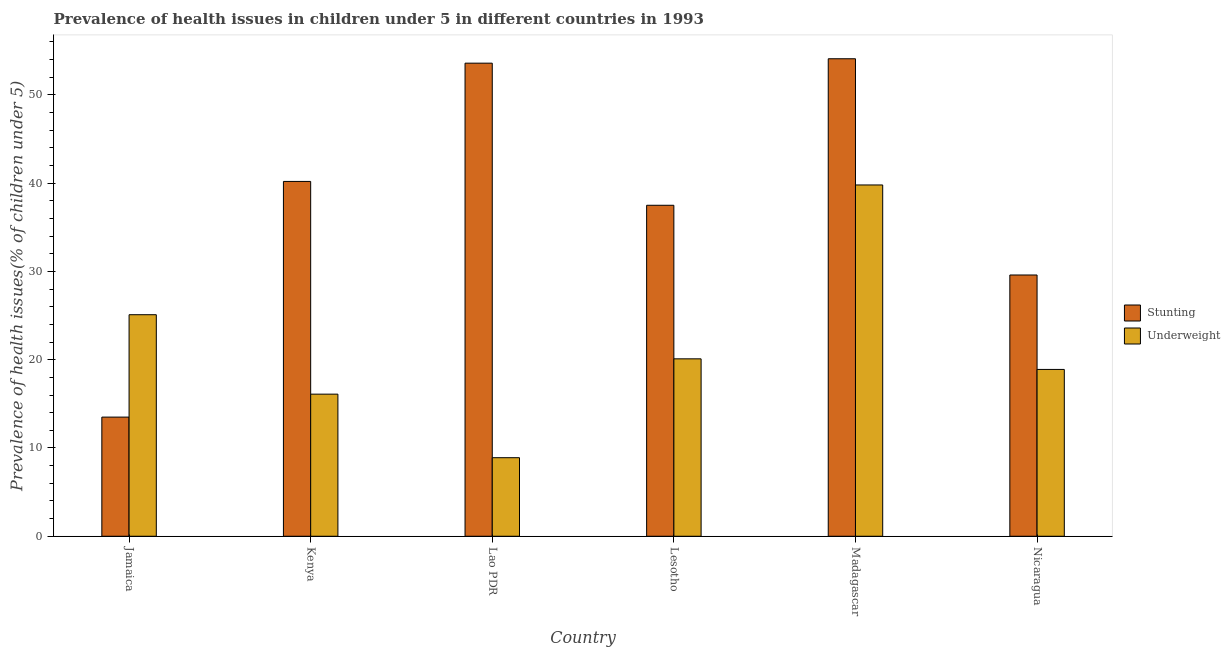Are the number of bars on each tick of the X-axis equal?
Your answer should be compact. Yes. What is the label of the 6th group of bars from the left?
Your response must be concise. Nicaragua. In how many cases, is the number of bars for a given country not equal to the number of legend labels?
Your answer should be compact. 0. What is the percentage of stunted children in Lao PDR?
Offer a terse response. 53.6. Across all countries, what is the maximum percentage of stunted children?
Keep it short and to the point. 54.1. In which country was the percentage of stunted children maximum?
Make the answer very short. Madagascar. In which country was the percentage of stunted children minimum?
Your answer should be very brief. Jamaica. What is the total percentage of underweight children in the graph?
Offer a terse response. 128.9. What is the difference between the percentage of underweight children in Madagascar and that in Nicaragua?
Provide a short and direct response. 20.9. What is the difference between the percentage of stunted children in Kenya and the percentage of underweight children in Lao PDR?
Your response must be concise. 31.3. What is the average percentage of stunted children per country?
Your answer should be very brief. 38.08. What is the difference between the percentage of stunted children and percentage of underweight children in Madagascar?
Provide a succinct answer. 14.3. In how many countries, is the percentage of stunted children greater than 28 %?
Offer a terse response. 5. What is the ratio of the percentage of stunted children in Lao PDR to that in Madagascar?
Your response must be concise. 0.99. What is the difference between the highest and the lowest percentage of stunted children?
Keep it short and to the point. 40.6. In how many countries, is the percentage of underweight children greater than the average percentage of underweight children taken over all countries?
Your response must be concise. 2. What does the 1st bar from the left in Nicaragua represents?
Provide a succinct answer. Stunting. What does the 1st bar from the right in Jamaica represents?
Make the answer very short. Underweight. How many countries are there in the graph?
Ensure brevity in your answer.  6. Does the graph contain grids?
Provide a short and direct response. No. How are the legend labels stacked?
Provide a succinct answer. Vertical. What is the title of the graph?
Make the answer very short. Prevalence of health issues in children under 5 in different countries in 1993. Does "Female population" appear as one of the legend labels in the graph?
Provide a succinct answer. No. What is the label or title of the Y-axis?
Ensure brevity in your answer.  Prevalence of health issues(% of children under 5). What is the Prevalence of health issues(% of children under 5) in Underweight in Jamaica?
Your response must be concise. 25.1. What is the Prevalence of health issues(% of children under 5) in Stunting in Kenya?
Your response must be concise. 40.2. What is the Prevalence of health issues(% of children under 5) of Underweight in Kenya?
Offer a terse response. 16.1. What is the Prevalence of health issues(% of children under 5) of Stunting in Lao PDR?
Your response must be concise. 53.6. What is the Prevalence of health issues(% of children under 5) in Underweight in Lao PDR?
Give a very brief answer. 8.9. What is the Prevalence of health issues(% of children under 5) in Stunting in Lesotho?
Give a very brief answer. 37.5. What is the Prevalence of health issues(% of children under 5) of Underweight in Lesotho?
Your answer should be very brief. 20.1. What is the Prevalence of health issues(% of children under 5) in Stunting in Madagascar?
Ensure brevity in your answer.  54.1. What is the Prevalence of health issues(% of children under 5) in Underweight in Madagascar?
Provide a succinct answer. 39.8. What is the Prevalence of health issues(% of children under 5) in Stunting in Nicaragua?
Your answer should be compact. 29.6. What is the Prevalence of health issues(% of children under 5) in Underweight in Nicaragua?
Your answer should be very brief. 18.9. Across all countries, what is the maximum Prevalence of health issues(% of children under 5) of Stunting?
Make the answer very short. 54.1. Across all countries, what is the maximum Prevalence of health issues(% of children under 5) of Underweight?
Ensure brevity in your answer.  39.8. Across all countries, what is the minimum Prevalence of health issues(% of children under 5) of Underweight?
Offer a terse response. 8.9. What is the total Prevalence of health issues(% of children under 5) of Stunting in the graph?
Provide a succinct answer. 228.5. What is the total Prevalence of health issues(% of children under 5) of Underweight in the graph?
Provide a succinct answer. 128.9. What is the difference between the Prevalence of health issues(% of children under 5) in Stunting in Jamaica and that in Kenya?
Provide a succinct answer. -26.7. What is the difference between the Prevalence of health issues(% of children under 5) in Underweight in Jamaica and that in Kenya?
Your answer should be very brief. 9. What is the difference between the Prevalence of health issues(% of children under 5) in Stunting in Jamaica and that in Lao PDR?
Your answer should be very brief. -40.1. What is the difference between the Prevalence of health issues(% of children under 5) of Stunting in Jamaica and that in Madagascar?
Your response must be concise. -40.6. What is the difference between the Prevalence of health issues(% of children under 5) of Underweight in Jamaica and that in Madagascar?
Your answer should be compact. -14.7. What is the difference between the Prevalence of health issues(% of children under 5) of Stunting in Jamaica and that in Nicaragua?
Offer a terse response. -16.1. What is the difference between the Prevalence of health issues(% of children under 5) in Underweight in Jamaica and that in Nicaragua?
Provide a short and direct response. 6.2. What is the difference between the Prevalence of health issues(% of children under 5) in Underweight in Kenya and that in Lao PDR?
Your answer should be compact. 7.2. What is the difference between the Prevalence of health issues(% of children under 5) of Stunting in Kenya and that in Madagascar?
Provide a short and direct response. -13.9. What is the difference between the Prevalence of health issues(% of children under 5) of Underweight in Kenya and that in Madagascar?
Make the answer very short. -23.7. What is the difference between the Prevalence of health issues(% of children under 5) in Underweight in Kenya and that in Nicaragua?
Provide a short and direct response. -2.8. What is the difference between the Prevalence of health issues(% of children under 5) in Stunting in Lao PDR and that in Lesotho?
Your answer should be very brief. 16.1. What is the difference between the Prevalence of health issues(% of children under 5) of Stunting in Lao PDR and that in Madagascar?
Ensure brevity in your answer.  -0.5. What is the difference between the Prevalence of health issues(% of children under 5) of Underweight in Lao PDR and that in Madagascar?
Keep it short and to the point. -30.9. What is the difference between the Prevalence of health issues(% of children under 5) of Stunting in Lao PDR and that in Nicaragua?
Your response must be concise. 24. What is the difference between the Prevalence of health issues(% of children under 5) in Stunting in Lesotho and that in Madagascar?
Ensure brevity in your answer.  -16.6. What is the difference between the Prevalence of health issues(% of children under 5) of Underweight in Lesotho and that in Madagascar?
Provide a succinct answer. -19.7. What is the difference between the Prevalence of health issues(% of children under 5) of Underweight in Lesotho and that in Nicaragua?
Keep it short and to the point. 1.2. What is the difference between the Prevalence of health issues(% of children under 5) of Stunting in Madagascar and that in Nicaragua?
Your answer should be compact. 24.5. What is the difference between the Prevalence of health issues(% of children under 5) of Underweight in Madagascar and that in Nicaragua?
Provide a short and direct response. 20.9. What is the difference between the Prevalence of health issues(% of children under 5) in Stunting in Jamaica and the Prevalence of health issues(% of children under 5) in Underweight in Lao PDR?
Your answer should be compact. 4.6. What is the difference between the Prevalence of health issues(% of children under 5) of Stunting in Jamaica and the Prevalence of health issues(% of children under 5) of Underweight in Madagascar?
Your response must be concise. -26.3. What is the difference between the Prevalence of health issues(% of children under 5) in Stunting in Kenya and the Prevalence of health issues(% of children under 5) in Underweight in Lao PDR?
Your response must be concise. 31.3. What is the difference between the Prevalence of health issues(% of children under 5) in Stunting in Kenya and the Prevalence of health issues(% of children under 5) in Underweight in Lesotho?
Make the answer very short. 20.1. What is the difference between the Prevalence of health issues(% of children under 5) of Stunting in Kenya and the Prevalence of health issues(% of children under 5) of Underweight in Madagascar?
Your answer should be very brief. 0.4. What is the difference between the Prevalence of health issues(% of children under 5) of Stunting in Kenya and the Prevalence of health issues(% of children under 5) of Underweight in Nicaragua?
Offer a terse response. 21.3. What is the difference between the Prevalence of health issues(% of children under 5) of Stunting in Lao PDR and the Prevalence of health issues(% of children under 5) of Underweight in Lesotho?
Provide a succinct answer. 33.5. What is the difference between the Prevalence of health issues(% of children under 5) of Stunting in Lao PDR and the Prevalence of health issues(% of children under 5) of Underweight in Madagascar?
Ensure brevity in your answer.  13.8. What is the difference between the Prevalence of health issues(% of children under 5) of Stunting in Lao PDR and the Prevalence of health issues(% of children under 5) of Underweight in Nicaragua?
Give a very brief answer. 34.7. What is the difference between the Prevalence of health issues(% of children under 5) in Stunting in Lesotho and the Prevalence of health issues(% of children under 5) in Underweight in Madagascar?
Offer a terse response. -2.3. What is the difference between the Prevalence of health issues(% of children under 5) of Stunting in Madagascar and the Prevalence of health issues(% of children under 5) of Underweight in Nicaragua?
Your response must be concise. 35.2. What is the average Prevalence of health issues(% of children under 5) in Stunting per country?
Your response must be concise. 38.08. What is the average Prevalence of health issues(% of children under 5) in Underweight per country?
Provide a succinct answer. 21.48. What is the difference between the Prevalence of health issues(% of children under 5) in Stunting and Prevalence of health issues(% of children under 5) in Underweight in Kenya?
Your answer should be compact. 24.1. What is the difference between the Prevalence of health issues(% of children under 5) in Stunting and Prevalence of health issues(% of children under 5) in Underweight in Lao PDR?
Provide a short and direct response. 44.7. What is the ratio of the Prevalence of health issues(% of children under 5) in Stunting in Jamaica to that in Kenya?
Ensure brevity in your answer.  0.34. What is the ratio of the Prevalence of health issues(% of children under 5) of Underweight in Jamaica to that in Kenya?
Provide a short and direct response. 1.56. What is the ratio of the Prevalence of health issues(% of children under 5) in Stunting in Jamaica to that in Lao PDR?
Keep it short and to the point. 0.25. What is the ratio of the Prevalence of health issues(% of children under 5) in Underweight in Jamaica to that in Lao PDR?
Provide a succinct answer. 2.82. What is the ratio of the Prevalence of health issues(% of children under 5) in Stunting in Jamaica to that in Lesotho?
Keep it short and to the point. 0.36. What is the ratio of the Prevalence of health issues(% of children under 5) of Underweight in Jamaica to that in Lesotho?
Offer a very short reply. 1.25. What is the ratio of the Prevalence of health issues(% of children under 5) of Stunting in Jamaica to that in Madagascar?
Keep it short and to the point. 0.25. What is the ratio of the Prevalence of health issues(% of children under 5) in Underweight in Jamaica to that in Madagascar?
Make the answer very short. 0.63. What is the ratio of the Prevalence of health issues(% of children under 5) of Stunting in Jamaica to that in Nicaragua?
Provide a short and direct response. 0.46. What is the ratio of the Prevalence of health issues(% of children under 5) in Underweight in Jamaica to that in Nicaragua?
Give a very brief answer. 1.33. What is the ratio of the Prevalence of health issues(% of children under 5) of Stunting in Kenya to that in Lao PDR?
Ensure brevity in your answer.  0.75. What is the ratio of the Prevalence of health issues(% of children under 5) of Underweight in Kenya to that in Lao PDR?
Keep it short and to the point. 1.81. What is the ratio of the Prevalence of health issues(% of children under 5) of Stunting in Kenya to that in Lesotho?
Ensure brevity in your answer.  1.07. What is the ratio of the Prevalence of health issues(% of children under 5) of Underweight in Kenya to that in Lesotho?
Your answer should be compact. 0.8. What is the ratio of the Prevalence of health issues(% of children under 5) in Stunting in Kenya to that in Madagascar?
Offer a terse response. 0.74. What is the ratio of the Prevalence of health issues(% of children under 5) of Underweight in Kenya to that in Madagascar?
Give a very brief answer. 0.4. What is the ratio of the Prevalence of health issues(% of children under 5) of Stunting in Kenya to that in Nicaragua?
Give a very brief answer. 1.36. What is the ratio of the Prevalence of health issues(% of children under 5) of Underweight in Kenya to that in Nicaragua?
Keep it short and to the point. 0.85. What is the ratio of the Prevalence of health issues(% of children under 5) in Stunting in Lao PDR to that in Lesotho?
Your response must be concise. 1.43. What is the ratio of the Prevalence of health issues(% of children under 5) in Underweight in Lao PDR to that in Lesotho?
Your answer should be compact. 0.44. What is the ratio of the Prevalence of health issues(% of children under 5) in Underweight in Lao PDR to that in Madagascar?
Provide a short and direct response. 0.22. What is the ratio of the Prevalence of health issues(% of children under 5) in Stunting in Lao PDR to that in Nicaragua?
Make the answer very short. 1.81. What is the ratio of the Prevalence of health issues(% of children under 5) in Underweight in Lao PDR to that in Nicaragua?
Offer a very short reply. 0.47. What is the ratio of the Prevalence of health issues(% of children under 5) of Stunting in Lesotho to that in Madagascar?
Offer a very short reply. 0.69. What is the ratio of the Prevalence of health issues(% of children under 5) of Underweight in Lesotho to that in Madagascar?
Keep it short and to the point. 0.51. What is the ratio of the Prevalence of health issues(% of children under 5) of Stunting in Lesotho to that in Nicaragua?
Provide a succinct answer. 1.27. What is the ratio of the Prevalence of health issues(% of children under 5) of Underweight in Lesotho to that in Nicaragua?
Your answer should be compact. 1.06. What is the ratio of the Prevalence of health issues(% of children under 5) in Stunting in Madagascar to that in Nicaragua?
Make the answer very short. 1.83. What is the ratio of the Prevalence of health issues(% of children under 5) in Underweight in Madagascar to that in Nicaragua?
Your answer should be very brief. 2.11. What is the difference between the highest and the lowest Prevalence of health issues(% of children under 5) of Stunting?
Make the answer very short. 40.6. What is the difference between the highest and the lowest Prevalence of health issues(% of children under 5) of Underweight?
Ensure brevity in your answer.  30.9. 